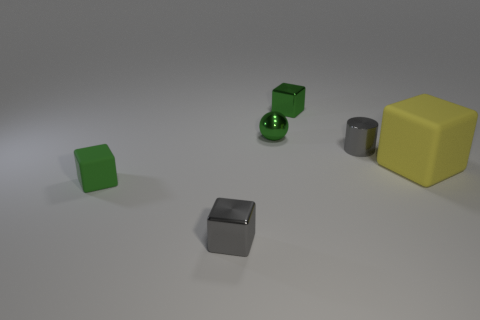Subtract all purple spheres. How many green blocks are left? 2 Subtract all yellow blocks. How many blocks are left? 3 Subtract all tiny gray cubes. How many cubes are left? 3 Add 2 shiny things. How many objects exist? 8 Subtract all cubes. How many objects are left? 2 Subtract all brown blocks. Subtract all yellow spheres. How many blocks are left? 4 Add 2 small metallic blocks. How many small metallic blocks are left? 4 Add 2 large metallic things. How many large metallic things exist? 2 Subtract 0 brown balls. How many objects are left? 6 Subtract all yellow things. Subtract all big green matte spheres. How many objects are left? 5 